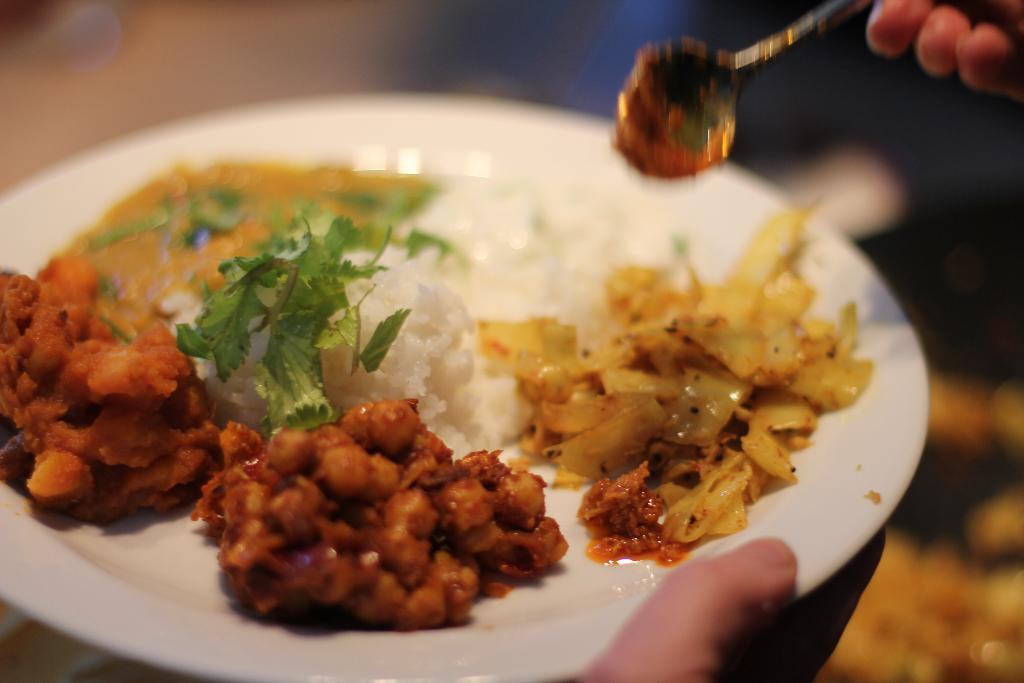What is on the plate in the image? There is a plate with food in the image. What utensil is visible in the image? There is a spoon in the top right of the image. What body part is visible in the top right of the image? There are fingers in the top right of the image. What body part is visible at the bottom of the image? There is a thumb at the bottom of the image. What type of pest can be seen crawling on the plate in the image? There is no pest visible on the plate in the image. What kind of chain is hanging from the spoon in the image? There is no chain hanging from the spoon in the image. 